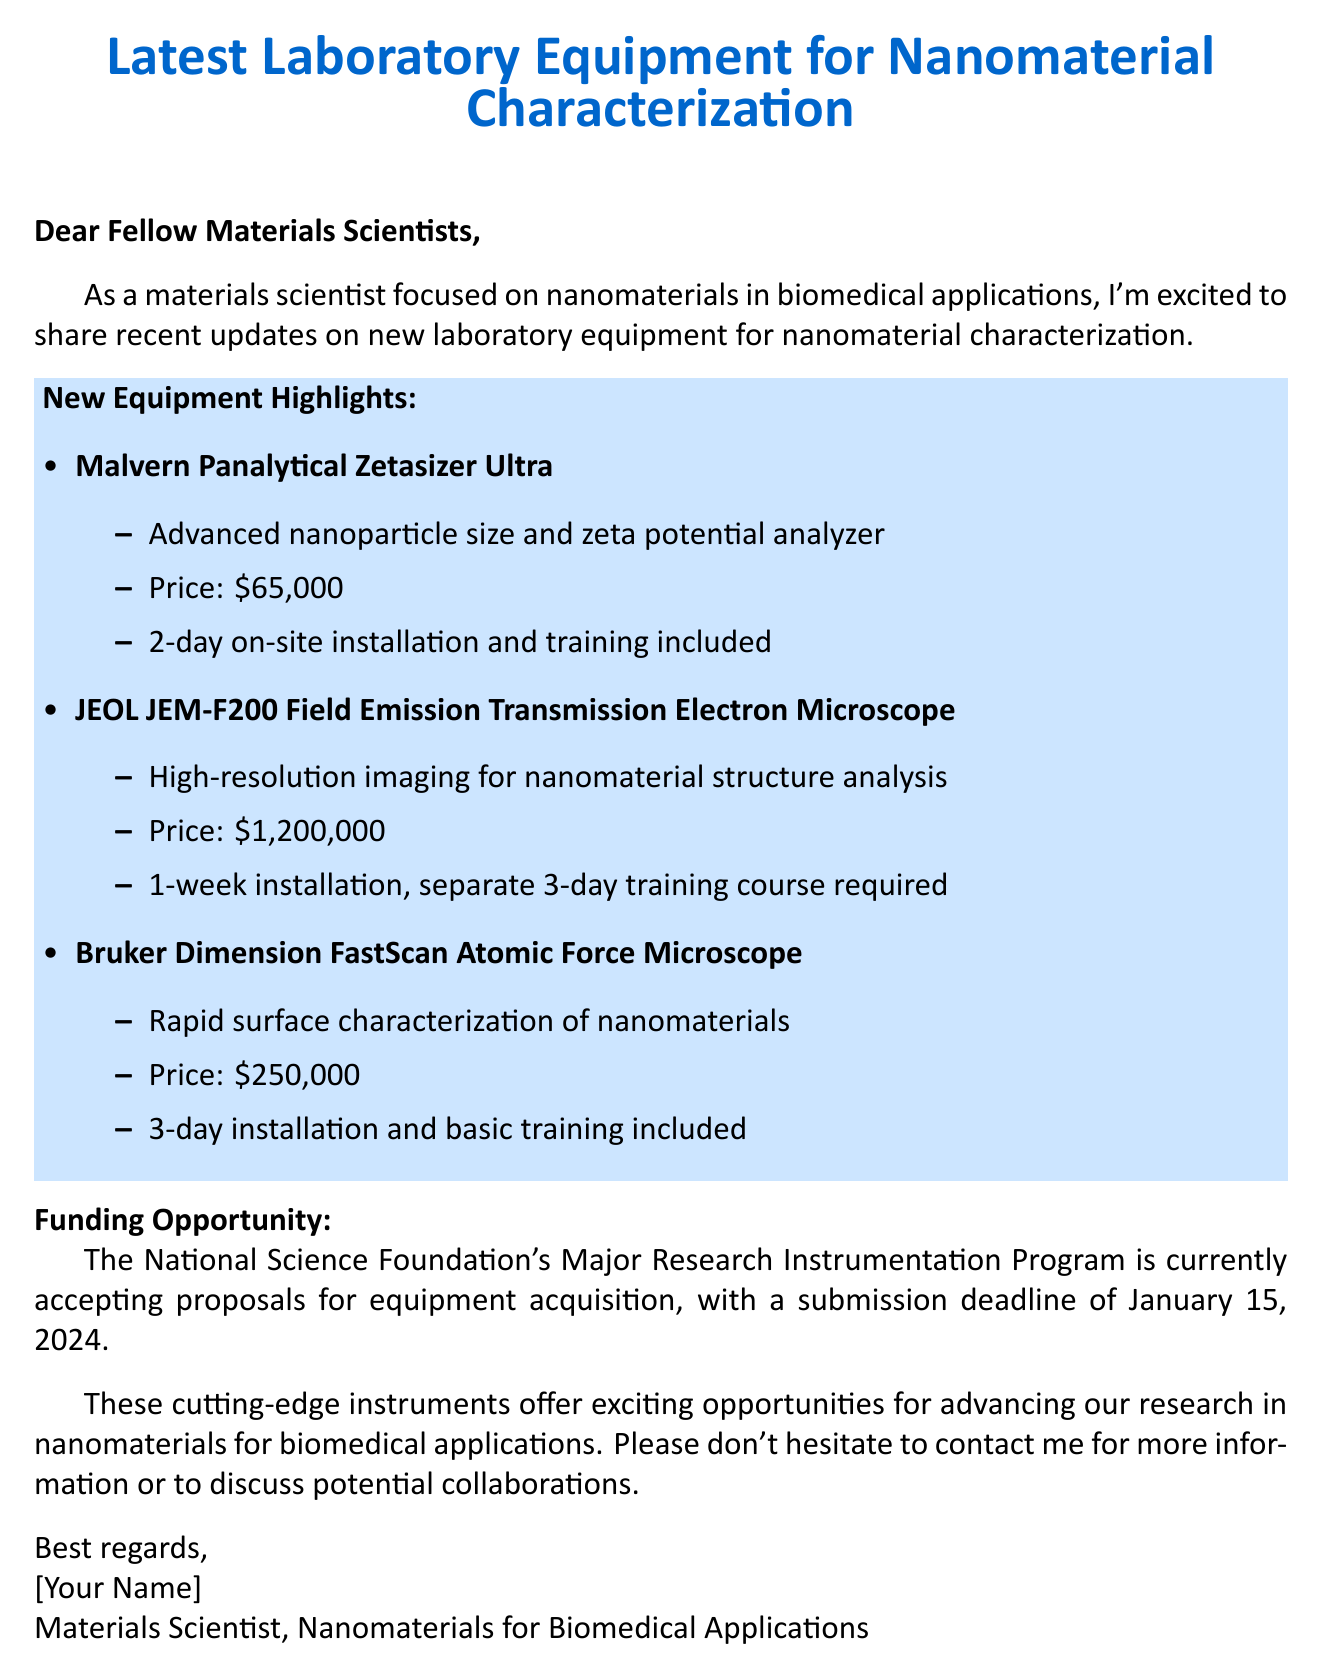What is the name of the advanced nanoparticle size analyzer? The document lists "Malvern Panalytical Zetasizer Ultra" as the advanced nanoparticle size and zeta potential analyzer.
Answer: Malvern Panalytical Zetasizer Ultra How much does the JEOL JEM-F200 microscope cost? The cost of the JEOL JEM-F200 Field Emission Transmission Electron Microscope is stated in the document as $1,200,000.
Answer: $1,200,000 What is the installation time for the Bruker Dimension FastScan? The installation time for the Bruker Dimension FastScan Atomic Force Microscope is specified as 3 days in the document.
Answer: 3-day What is the deadline for the NSF funding proposal? The document mentions that the submission deadline for the NSF's Major Research Instrumentation Program proposals is January 15, 2024.
Answer: January 15, 2024 Which equipment has an included training course? The Malvern Panalytical Zetasizer Ultra and Bruker Dimension FastScan both include training, while the JEOL JEM-F200 requires a separate training course.
Answer: Malvern Panalytical Zetasizer Ultra; Bruker Dimension FastScan What is the primary application focus of the equipment mentioned? The introduction states that the equipment is relevant for nanomaterials in biomedical applications, highlighting their intended use.
Answer: nanomaterials in biomedical applications How long is the training course required for the JEOL JEM-F200? The document specifies that the JEOL JEM-F200 requires a separate training course of 3 days after the week-long installation.
Answer: 3-day What color is used for the title of the document? The document indicates that the title is displayed in a specific RGB color which corresponds to a blue shade.
Answer: blue 